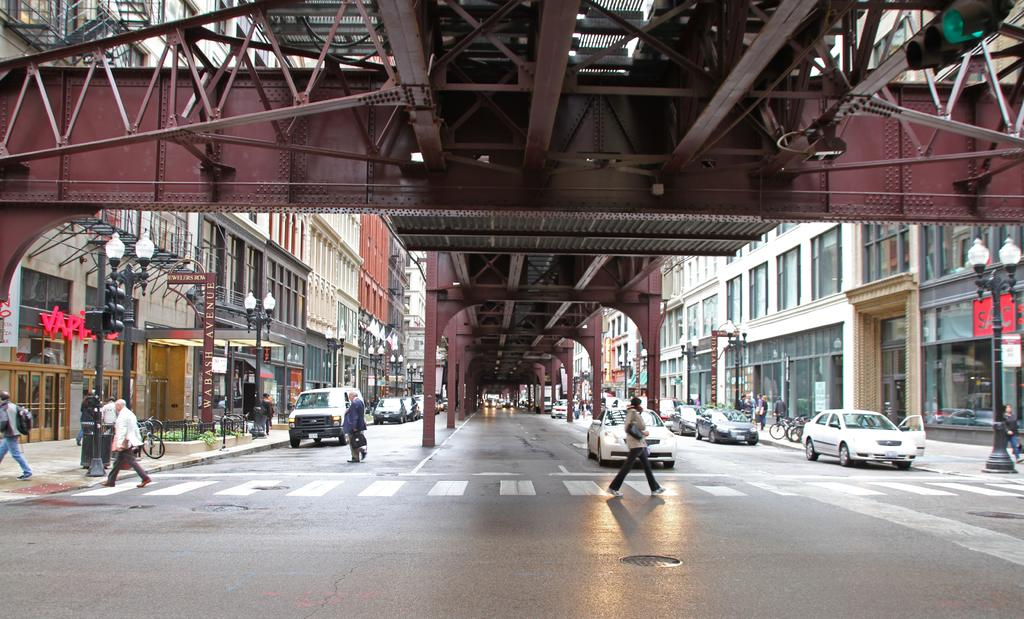<image>
Describe the image concisely. A road with people passing by and a store called SAC on the right side. 